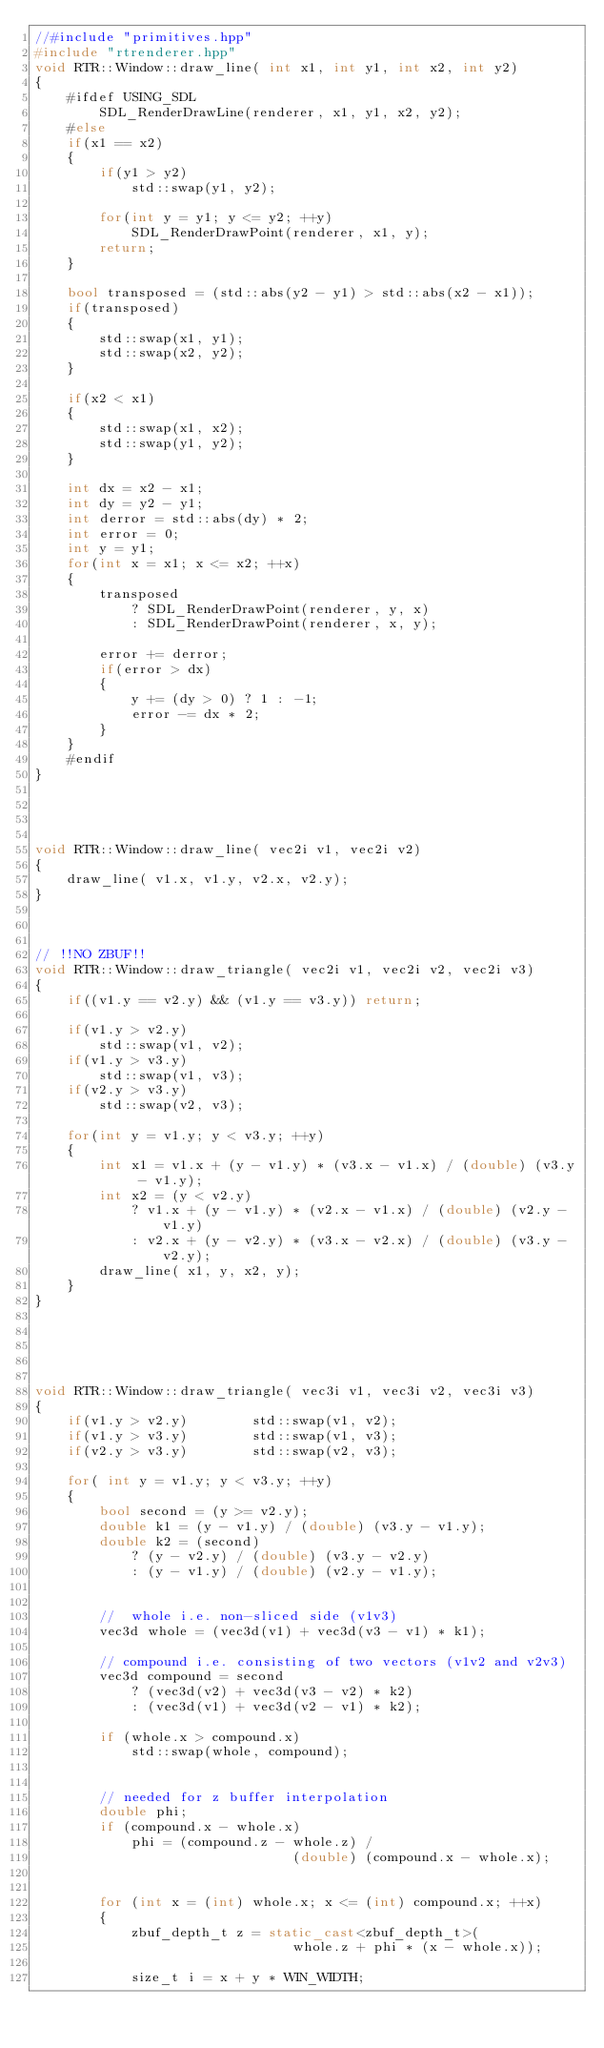Convert code to text. <code><loc_0><loc_0><loc_500><loc_500><_C++_>//#include "primitives.hpp"
#include "rtrenderer.hpp"
void RTR::Window::draw_line( int x1, int y1, int x2, int y2)
{
    #ifdef USING_SDL
        SDL_RenderDrawLine(renderer, x1, y1, x2, y2);
    #else
    if(x1 == x2)
    {
        if(y1 > y2)
            std::swap(y1, y2);
            
        for(int y = y1; y <= y2; ++y)
            SDL_RenderDrawPoint(renderer, x1, y);
        return;
    }

    bool transposed = (std::abs(y2 - y1) > std::abs(x2 - x1));
    if(transposed)
    {
        std::swap(x1, y1);
        std::swap(x2, y2);
    }

    if(x2 < x1)
    {
        std::swap(x1, x2);
        std::swap(y1, y2);
    }

    int dx = x2 - x1;
    int dy = y2 - y1;
    int derror = std::abs(dy) * 2;
    int error = 0;
    int y = y1;
    for(int x = x1; x <= x2; ++x)
    {
        transposed
            ? SDL_RenderDrawPoint(renderer, y, x)
            : SDL_RenderDrawPoint(renderer, x, y);

        error += derror;
        if(error > dx)
        {
            y += (dy > 0) ? 1 : -1;
            error -= dx * 2;
        }
    }
    #endif
}




void RTR::Window::draw_line( vec2i v1, vec2i v2)
{
    draw_line( v1.x, v1.y, v2.x, v2.y);
}



// !!NO ZBUF!!
void RTR::Window::draw_triangle( vec2i v1, vec2i v2, vec2i v3)
{
    if((v1.y == v2.y) && (v1.y == v3.y)) return;

    if(v1.y > v2.y)
        std::swap(v1, v2);
    if(v1.y > v3.y)
        std::swap(v1, v3);
    if(v2.y > v3.y)
        std::swap(v2, v3);

    for(int y = v1.y; y < v3.y; ++y)
    {
        int x1 = v1.x + (y - v1.y) * (v3.x - v1.x) / (double) (v3.y - v1.y);
        int x2 = (y < v2.y)
            ? v1.x + (y - v1.y) * (v2.x - v1.x) / (double) (v2.y - v1.y)
            : v2.x + (y - v2.y) * (v3.x - v2.x) / (double) (v3.y - v2.y);
        draw_line( x1, y, x2, y);
    }
}





void RTR::Window::draw_triangle( vec3i v1, vec3i v2, vec3i v3)
{
    if(v1.y > v2.y)        std::swap(v1, v2);
    if(v1.y > v3.y)        std::swap(v1, v3);
    if(v2.y > v3.y)        std::swap(v2, v3);

    for( int y = v1.y; y < v3.y; ++y)
    {
        bool second = (y >= v2.y);
        double k1 = (y - v1.y) / (double) (v3.y - v1.y);
        double k2 = (second)
            ? (y - v2.y) / (double) (v3.y - v2.y)
            : (y - v1.y) / (double) (v2.y - v1.y);


        //  whole i.e. non-sliced side (v1v3)
        vec3d whole = (vec3d(v1) + vec3d(v3 - v1) * k1);
        
        // compound i.e. consisting of two vectors (v1v2 and v2v3)
        vec3d compound = second
            ? (vec3d(v2) + vec3d(v3 - v2) * k2)
            : (vec3d(v1) + vec3d(v2 - v1) * k2);

        if (whole.x > compound.x)
            std::swap(whole, compound);
            

        // needed for z buffer interpolation 
        double phi;
        if (compound.x - whole.x)
            phi = (compound.z - whole.z) /
                                (double) (compound.x - whole.x);

 
        for (int x = (int) whole.x; x <= (int) compound.x; ++x)
        {
            zbuf_depth_t z = static_cast<zbuf_depth_t>(
                                whole.z + phi * (x - whole.x));
                                
            size_t i = x + y * WIN_WIDTH;
</code> 